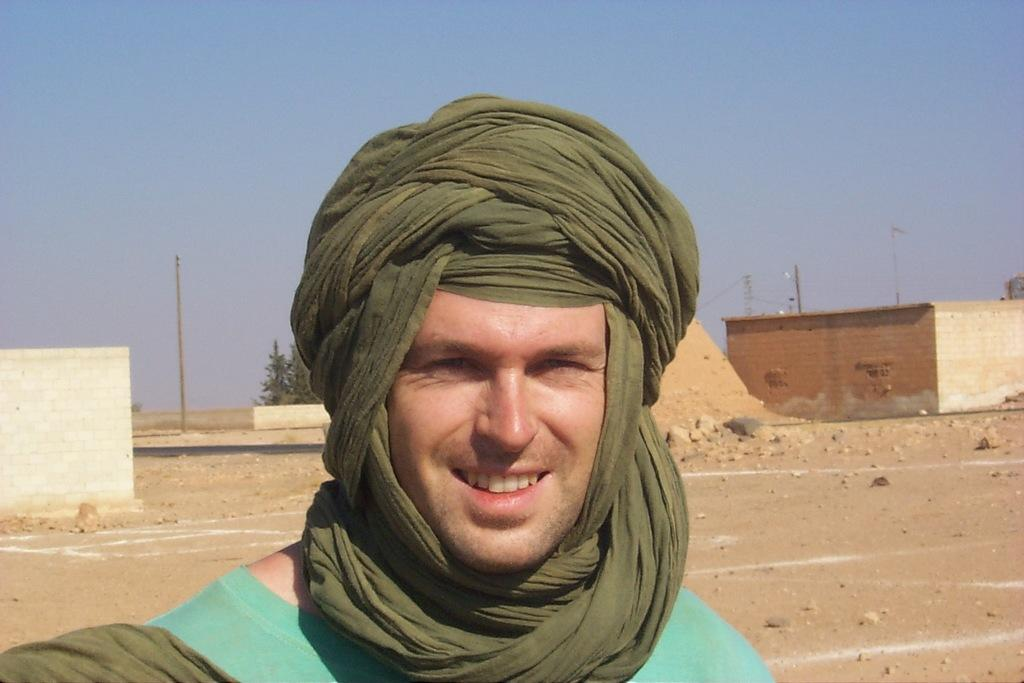Who or what is present in the image? There is a person in the image. What is the facial expression of the person? The person has a smile on their face. What can be seen in the distance behind the person? There are houses, trees, and the sky visible in the background of the image. What type of net is being used by the person in the image? There is no net present in the image; it features a person with a smile and a background of houses, trees, and the sky. 